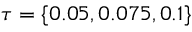<formula> <loc_0><loc_0><loc_500><loc_500>\tau = \{ 0 . 0 5 , 0 . 0 7 5 , 0 . 1 \}</formula> 